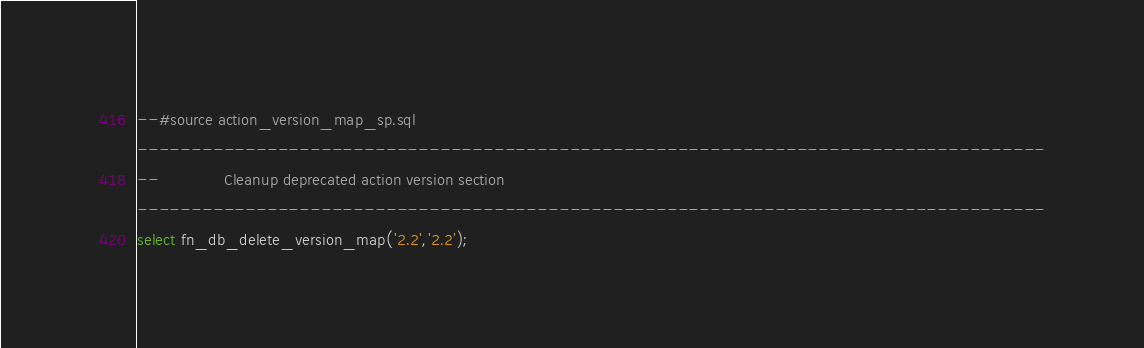Convert code to text. <code><loc_0><loc_0><loc_500><loc_500><_SQL_>--#source action_version_map_sp.sql
------------------------------------------------------------------------------------
--              Cleanup deprecated action version section
------------------------------------------------------------------------------------
select fn_db_delete_version_map('2.2','2.2');
</code> 